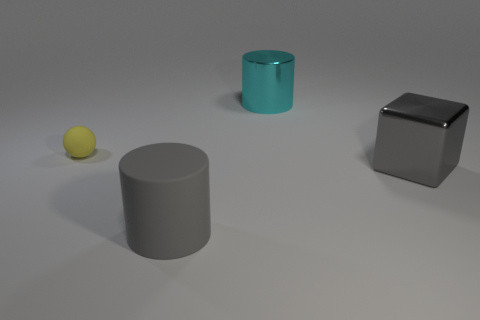Is there anything else that is the same color as the shiny cube?
Offer a very short reply. Yes. The other big thing that is the same color as the big matte thing is what shape?
Offer a terse response. Cube. Do the block and the large object that is in front of the gray metallic block have the same color?
Make the answer very short. Yes. Are there any gray metallic objects that have the same size as the cyan cylinder?
Ensure brevity in your answer.  Yes. Is the number of gray things that are right of the cyan metal object greater than the number of yellow rubber things that are on the right side of the gray metal block?
Offer a very short reply. Yes. Are the big cyan cylinder and the large cylinder in front of the big gray shiny thing made of the same material?
Offer a terse response. No. There is a object to the right of the metal thing on the left side of the gray shiny cube; how many yellow matte balls are in front of it?
Offer a very short reply. 0. There is a gray rubber object; does it have the same shape as the matte thing behind the big gray metal thing?
Make the answer very short. No. There is a large object that is both in front of the matte sphere and on the left side of the cube; what color is it?
Provide a succinct answer. Gray. What material is the gray thing that is left of the gray thing behind the large object that is on the left side of the large cyan cylinder?
Offer a terse response. Rubber. 